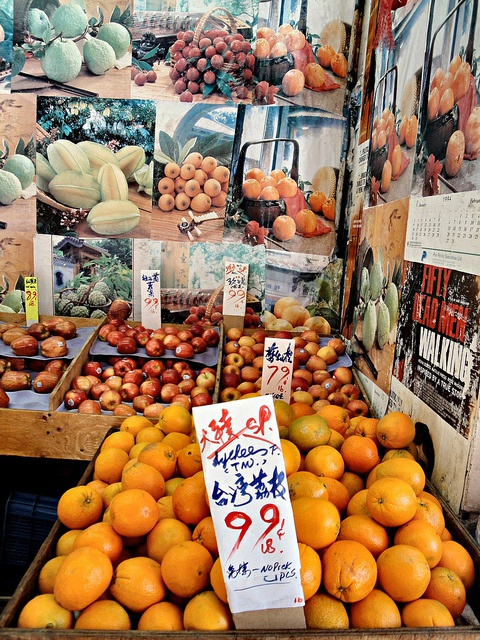Describe the objects in this image and their specific colors. I can see orange in turquoise, orange, red, and maroon tones, orange in turquoise, orange, red, and maroon tones, apple in turquoise, orange, maroon, brown, and black tones, apple in turquoise, brown, maroon, red, and black tones, and apple in turquoise, maroon, red, and orange tones in this image. 